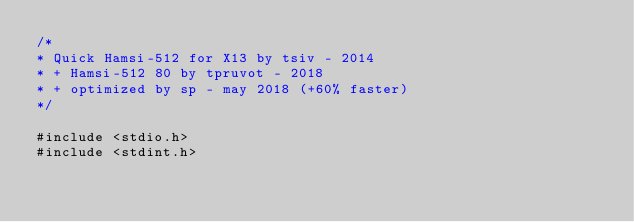Convert code to text. <code><loc_0><loc_0><loc_500><loc_500><_Cuda_>/*
* Quick Hamsi-512 for X13 by tsiv - 2014
* + Hamsi-512 80 by tpruvot - 2018
* + optimized by sp - may 2018 (+60% faster)
*/

#include <stdio.h>
#include <stdint.h></code> 